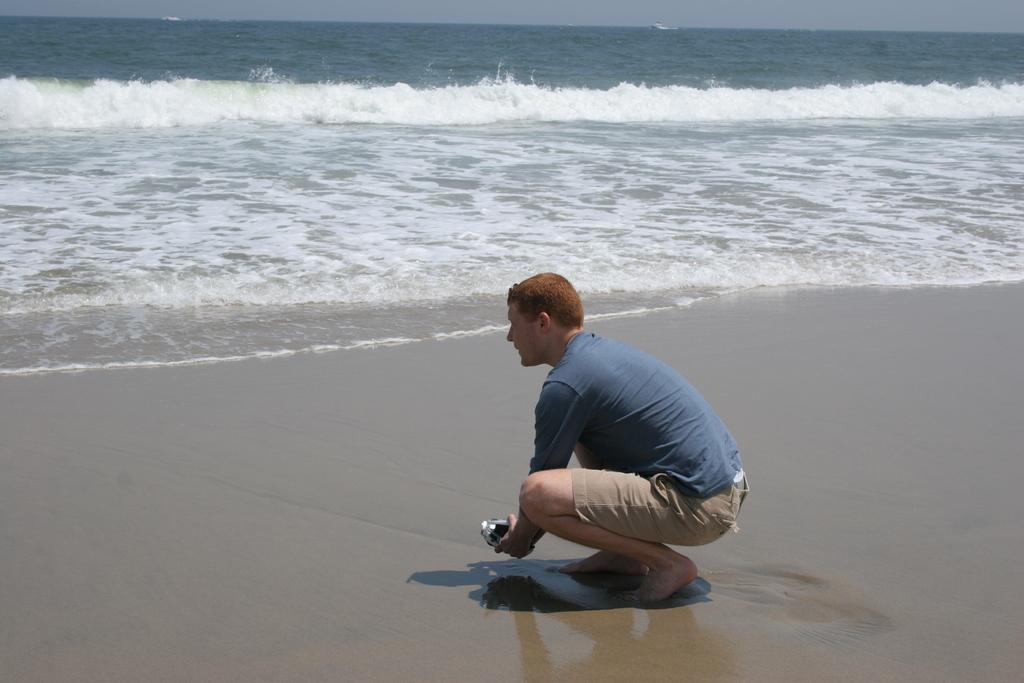Who is in the image? There is a person in the image. What is the person wearing? The person is wearing a blue T-shirt. Where is the person located in the image? The person is on the sand. What position is the person in? A: The person is in a squat position. What can be seen in the background of the image? There are waves, water, and the sky visible in the background of the image. How many cobwebs can be seen in the image? There are no cobwebs present in the image. What type of branch is the person holding in the image? There is no branch present in the image. 